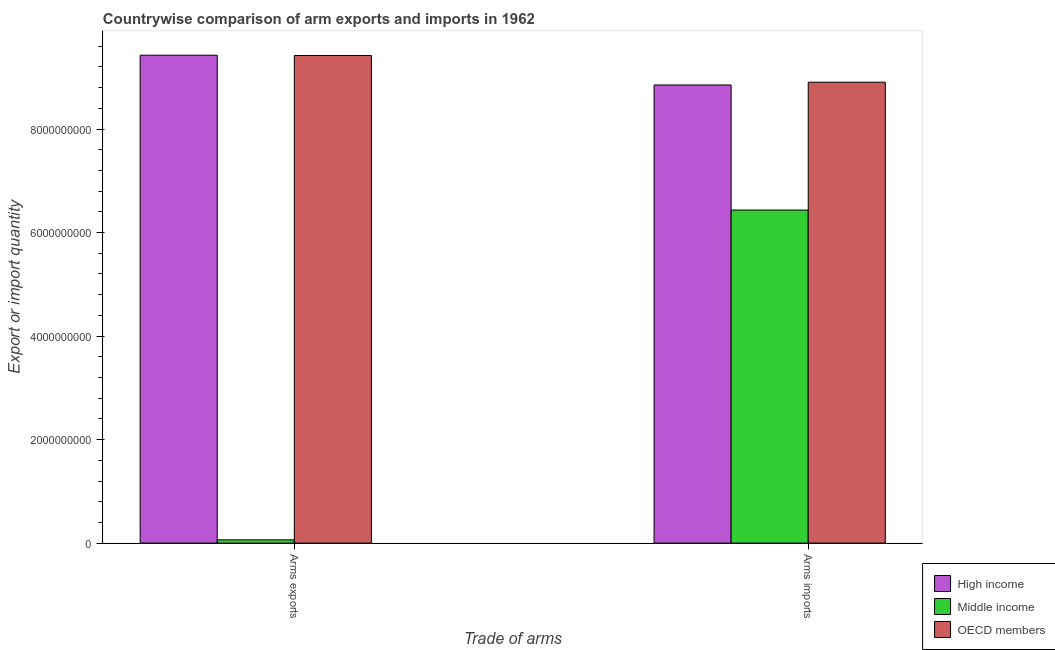How many different coloured bars are there?
Your answer should be compact. 3. How many groups of bars are there?
Your answer should be compact. 2. Are the number of bars per tick equal to the number of legend labels?
Your response must be concise. Yes. What is the label of the 1st group of bars from the left?
Your answer should be very brief. Arms exports. What is the arms imports in OECD members?
Provide a succinct answer. 8.90e+09. Across all countries, what is the maximum arms exports?
Keep it short and to the point. 9.43e+09. Across all countries, what is the minimum arms exports?
Give a very brief answer. 6.30e+07. In which country was the arms exports minimum?
Your answer should be compact. Middle income. What is the total arms exports in the graph?
Provide a succinct answer. 1.89e+1. What is the difference between the arms exports in High income and that in OECD members?
Provide a succinct answer. 6.00e+06. What is the difference between the arms imports in Middle income and the arms exports in High income?
Make the answer very short. -2.99e+09. What is the average arms imports per country?
Ensure brevity in your answer.  8.06e+09. What is the difference between the arms exports and arms imports in OECD members?
Your answer should be very brief. 5.15e+08. What is the ratio of the arms imports in OECD members to that in Middle income?
Your answer should be very brief. 1.38. In how many countries, is the arms exports greater than the average arms exports taken over all countries?
Your response must be concise. 2. What does the 1st bar from the left in Arms exports represents?
Your response must be concise. High income. What does the 1st bar from the right in Arms imports represents?
Your answer should be compact. OECD members. How many bars are there?
Your answer should be very brief. 6. Does the graph contain grids?
Your answer should be compact. No. How are the legend labels stacked?
Give a very brief answer. Vertical. What is the title of the graph?
Keep it short and to the point. Countrywise comparison of arm exports and imports in 1962. Does "Saudi Arabia" appear as one of the legend labels in the graph?
Ensure brevity in your answer.  No. What is the label or title of the X-axis?
Make the answer very short. Trade of arms. What is the label or title of the Y-axis?
Offer a very short reply. Export or import quantity. What is the Export or import quantity in High income in Arms exports?
Your answer should be very brief. 9.43e+09. What is the Export or import quantity of Middle income in Arms exports?
Your answer should be compact. 6.30e+07. What is the Export or import quantity in OECD members in Arms exports?
Ensure brevity in your answer.  9.42e+09. What is the Export or import quantity in High income in Arms imports?
Keep it short and to the point. 8.85e+09. What is the Export or import quantity in Middle income in Arms imports?
Provide a short and direct response. 6.44e+09. What is the Export or import quantity of OECD members in Arms imports?
Give a very brief answer. 8.90e+09. Across all Trade of arms, what is the maximum Export or import quantity of High income?
Keep it short and to the point. 9.43e+09. Across all Trade of arms, what is the maximum Export or import quantity of Middle income?
Offer a very short reply. 6.44e+09. Across all Trade of arms, what is the maximum Export or import quantity in OECD members?
Provide a succinct answer. 9.42e+09. Across all Trade of arms, what is the minimum Export or import quantity in High income?
Provide a succinct answer. 8.85e+09. Across all Trade of arms, what is the minimum Export or import quantity in Middle income?
Provide a succinct answer. 6.30e+07. Across all Trade of arms, what is the minimum Export or import quantity of OECD members?
Provide a short and direct response. 8.90e+09. What is the total Export or import quantity of High income in the graph?
Your answer should be very brief. 1.83e+1. What is the total Export or import quantity in Middle income in the graph?
Keep it short and to the point. 6.50e+09. What is the total Export or import quantity in OECD members in the graph?
Give a very brief answer. 1.83e+1. What is the difference between the Export or import quantity in High income in Arms exports and that in Arms imports?
Make the answer very short. 5.75e+08. What is the difference between the Export or import quantity in Middle income in Arms exports and that in Arms imports?
Your answer should be compact. -6.37e+09. What is the difference between the Export or import quantity of OECD members in Arms exports and that in Arms imports?
Your response must be concise. 5.15e+08. What is the difference between the Export or import quantity in High income in Arms exports and the Export or import quantity in Middle income in Arms imports?
Make the answer very short. 2.99e+09. What is the difference between the Export or import quantity in High income in Arms exports and the Export or import quantity in OECD members in Arms imports?
Keep it short and to the point. 5.21e+08. What is the difference between the Export or import quantity in Middle income in Arms exports and the Export or import quantity in OECD members in Arms imports?
Make the answer very short. -8.84e+09. What is the average Export or import quantity of High income per Trade of arms?
Provide a succinct answer. 9.14e+09. What is the average Export or import quantity of Middle income per Trade of arms?
Make the answer very short. 3.25e+09. What is the average Export or import quantity of OECD members per Trade of arms?
Provide a succinct answer. 9.16e+09. What is the difference between the Export or import quantity in High income and Export or import quantity in Middle income in Arms exports?
Keep it short and to the point. 9.36e+09. What is the difference between the Export or import quantity in High income and Export or import quantity in OECD members in Arms exports?
Your response must be concise. 6.00e+06. What is the difference between the Export or import quantity of Middle income and Export or import quantity of OECD members in Arms exports?
Keep it short and to the point. -9.36e+09. What is the difference between the Export or import quantity in High income and Export or import quantity in Middle income in Arms imports?
Offer a terse response. 2.42e+09. What is the difference between the Export or import quantity of High income and Export or import quantity of OECD members in Arms imports?
Give a very brief answer. -5.40e+07. What is the difference between the Export or import quantity of Middle income and Export or import quantity of OECD members in Arms imports?
Offer a very short reply. -2.47e+09. What is the ratio of the Export or import quantity of High income in Arms exports to that in Arms imports?
Your response must be concise. 1.06. What is the ratio of the Export or import quantity in Middle income in Arms exports to that in Arms imports?
Keep it short and to the point. 0.01. What is the ratio of the Export or import quantity of OECD members in Arms exports to that in Arms imports?
Offer a terse response. 1.06. What is the difference between the highest and the second highest Export or import quantity of High income?
Your response must be concise. 5.75e+08. What is the difference between the highest and the second highest Export or import quantity of Middle income?
Provide a short and direct response. 6.37e+09. What is the difference between the highest and the second highest Export or import quantity of OECD members?
Offer a terse response. 5.15e+08. What is the difference between the highest and the lowest Export or import quantity in High income?
Keep it short and to the point. 5.75e+08. What is the difference between the highest and the lowest Export or import quantity in Middle income?
Ensure brevity in your answer.  6.37e+09. What is the difference between the highest and the lowest Export or import quantity in OECD members?
Provide a short and direct response. 5.15e+08. 